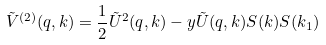<formula> <loc_0><loc_0><loc_500><loc_500>\tilde { V } ^ { ( 2 ) } ( q , k ) = \frac { 1 } { 2 } \tilde { U } ^ { 2 } ( q , k ) - y \tilde { U } ( q , k ) S ( k ) S ( k _ { 1 } )</formula> 